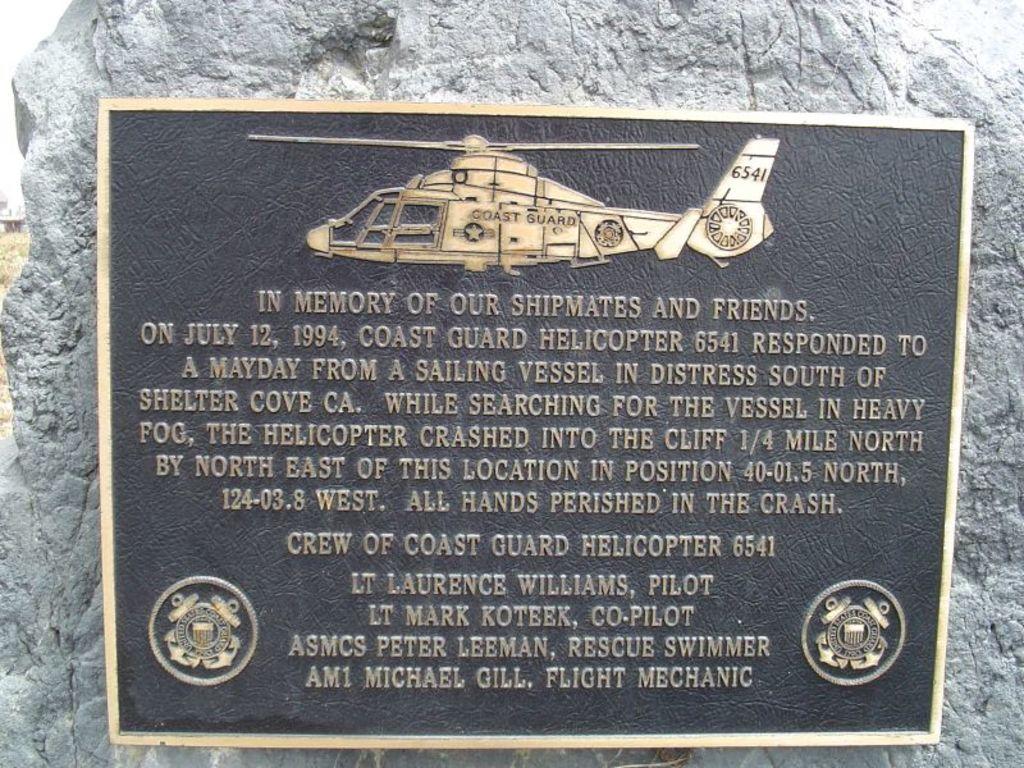Who is this in memory of?
Ensure brevity in your answer.  Shipmates and friends. 